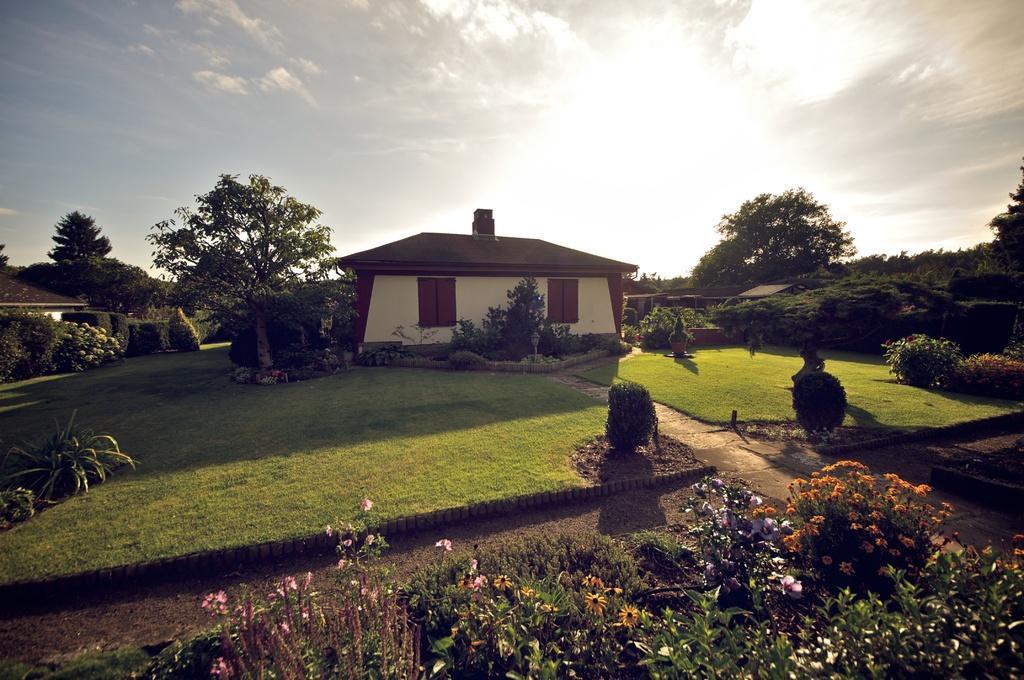Describe this image in one or two sentences. In this picture I can see plants with flowers, grass, trees, houses, and in the background there is sky. 